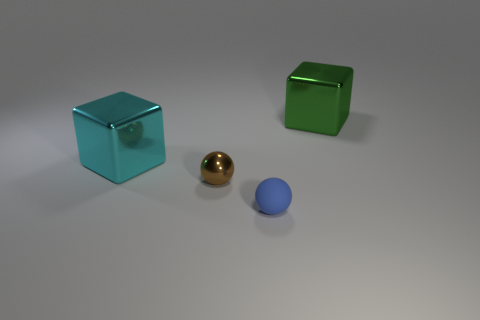Add 2 cyan cubes. How many objects exist? 6 Add 4 cyan blocks. How many cyan blocks exist? 5 Subtract 1 brown balls. How many objects are left? 3 Subtract all big cyan shiny blocks. Subtract all small blue rubber balls. How many objects are left? 2 Add 1 tiny things. How many tiny things are left? 3 